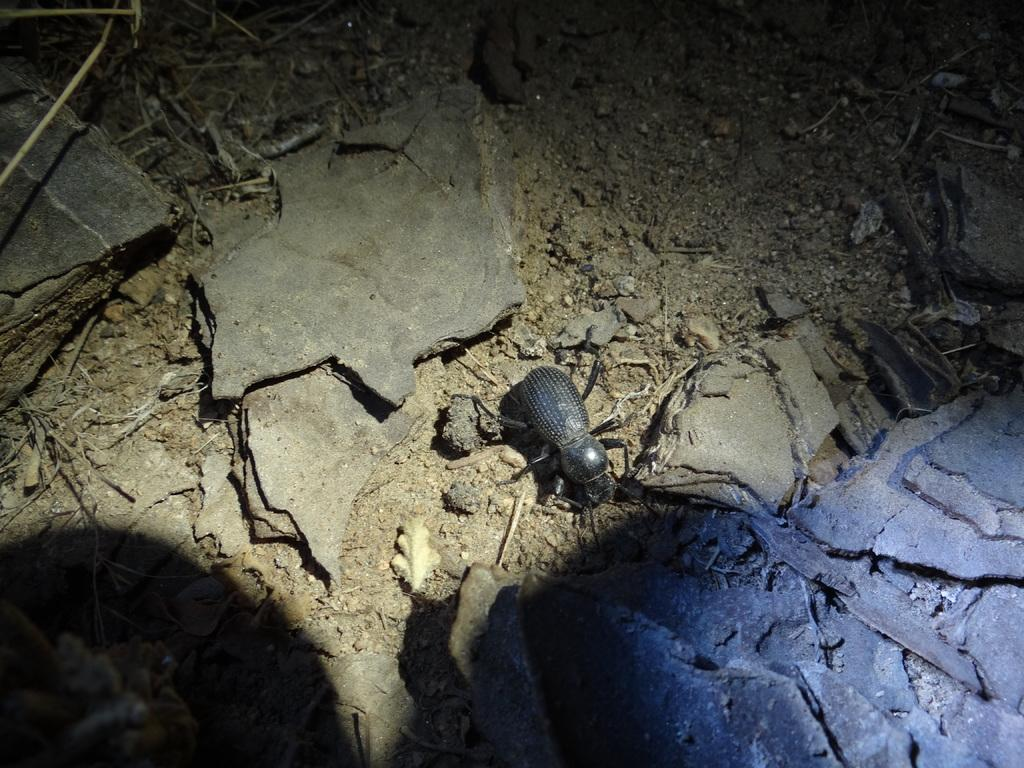What type of creature can be seen in the image? There is an insect in the image. Where is the insect located in the image? The insect is on the ground. What type of insurance does the pet in the image have? There is no pet present in the image, only an insect. What type of wood can be seen in the image? There is no wood present in the image; it only features an insect on the ground. 